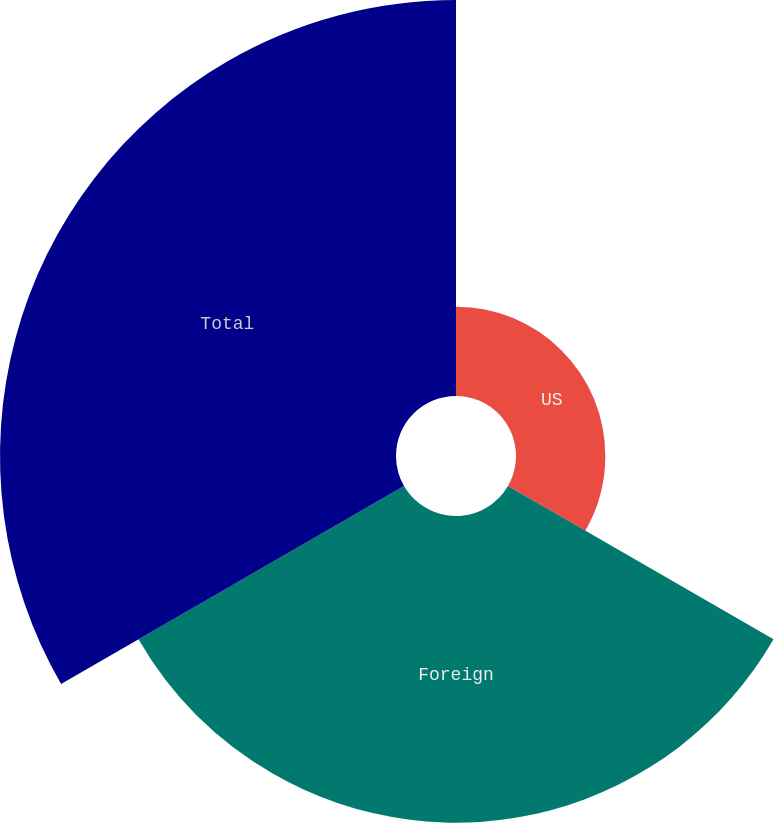<chart> <loc_0><loc_0><loc_500><loc_500><pie_chart><fcel>US<fcel>Foreign<fcel>Total<nl><fcel>11.28%<fcel>38.72%<fcel>50.0%<nl></chart> 